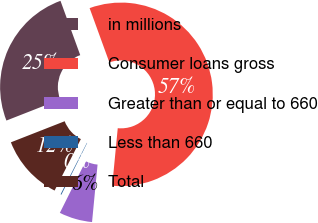<chart> <loc_0><loc_0><loc_500><loc_500><pie_chart><fcel>in millions<fcel>Consumer loans gross<fcel>Greater than or equal to 660<fcel>Less than 660<fcel>Total<nl><fcel>25.39%<fcel>57.08%<fcel>5.84%<fcel>0.15%<fcel>11.54%<nl></chart> 